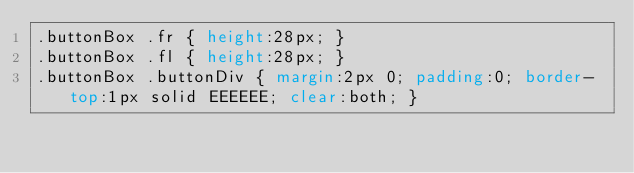Convert code to text. <code><loc_0><loc_0><loc_500><loc_500><_CSS_>.buttonBox .fr { height:28px; }
.buttonBox .fl { height:28px; }
.buttonBox .buttonDiv { margin:2px 0; padding:0; border-top:1px solid EEEEEE; clear:both; }
</code> 